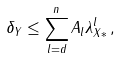<formula> <loc_0><loc_0><loc_500><loc_500>\delta _ { Y } & \leq \sum _ { l = d } ^ { n } A _ { l } \lambda _ { X * } ^ { l } \, ,</formula> 